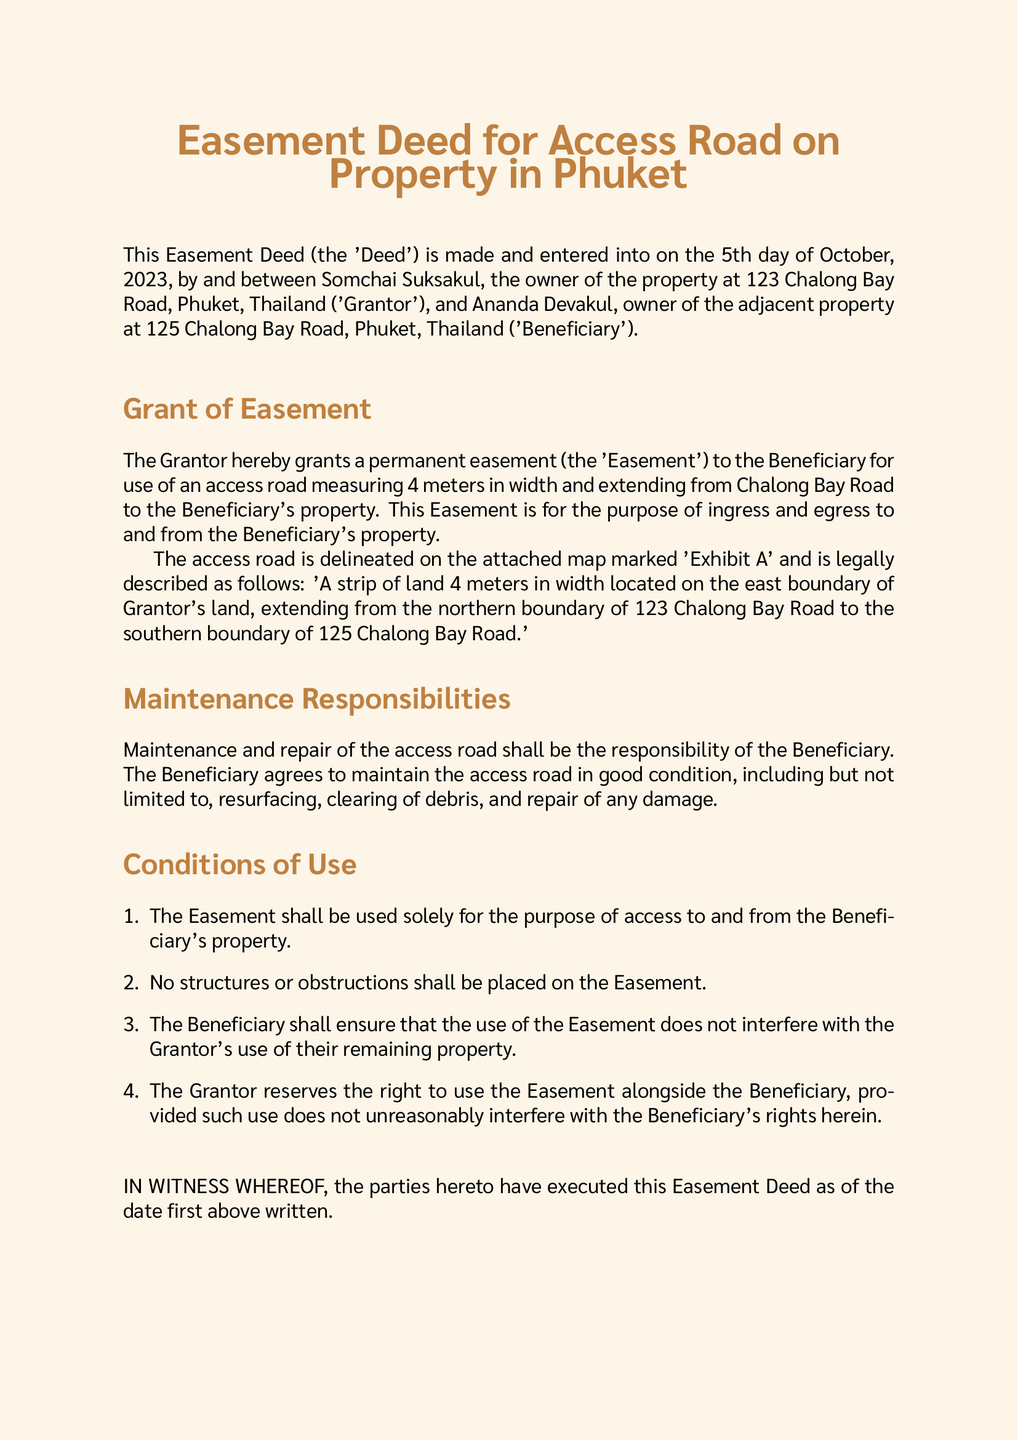What is the date of the Deed? The date of the Deed is stated at the beginning of the document.
Answer: 5th day of October, 2023 Who is the Grantor? The Grantor is mentioned in the introduction of the Deed.
Answer: Somchai Suksakul What is the width of the access road? The width of the access road is specified in the Grant of Easement section.
Answer: 4 meters What is the primary purpose of the Easement? The purpose of the Easement is defined in the Grant of Easement section.
Answer: ingress and egress Who is responsible for the maintenance of the access road? The responsibility for maintenance is outlined in the Maintenance Responsibilities section.
Answer: Beneficiary Can structures be placed on the Easement? The conditions regarding structures are detailed in the Conditions of Use section.
Answer: No What must the Beneficiary ensure regarding the Grantor's property? The conditions regarding the Beneficiary's obligations are also outlined in the Conditions of Use section.
Answer: does not interfere Who signed as the Witness? The name of the Witness is listed at the end of the document.
Answer: Nattawat Panyaprasit 